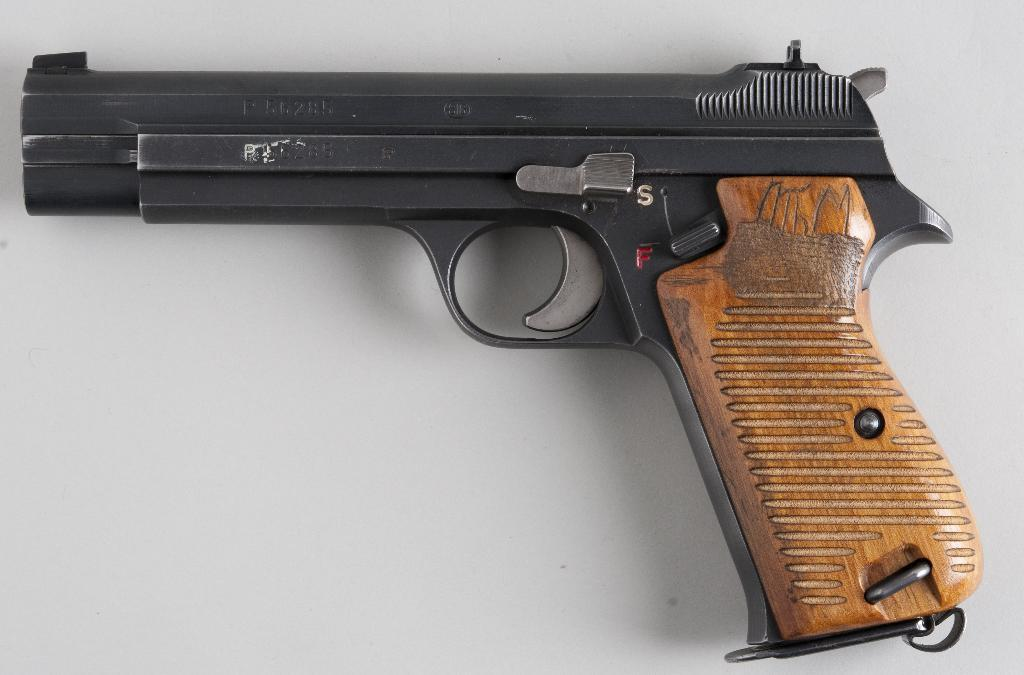What object is the main subject of the picture? There is a gun in the picture. What is the color of the gun? The gun is black in color, with some parts of the handle being brown. What is the gun placed on in the picture? The gun is placed on a white surface. Can you see any rabbits or trains in the picture? No, there are no rabbits or trains present in the image. What type of sleet is falling on the gun in the picture? There is no sleet present in the image; it is a picture of a gun placed on a white surface. 